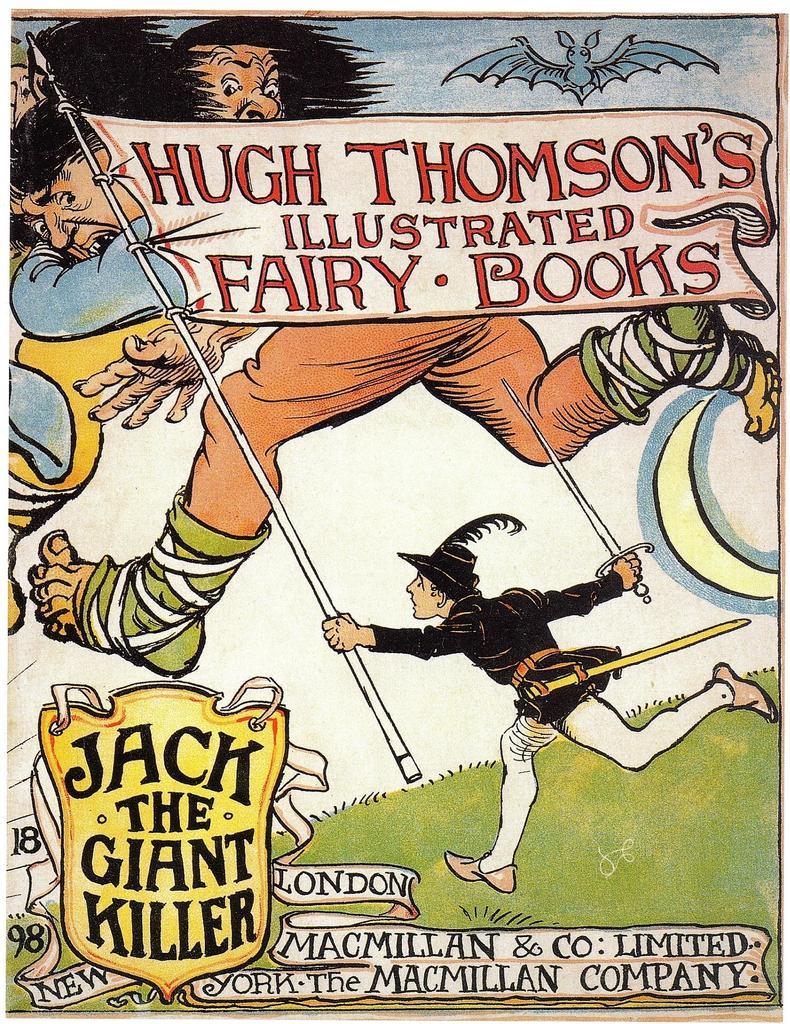Who is the author of the book?
Make the answer very short. Hugh thomson. Who is the giant killer?
Your answer should be compact. Jack. 